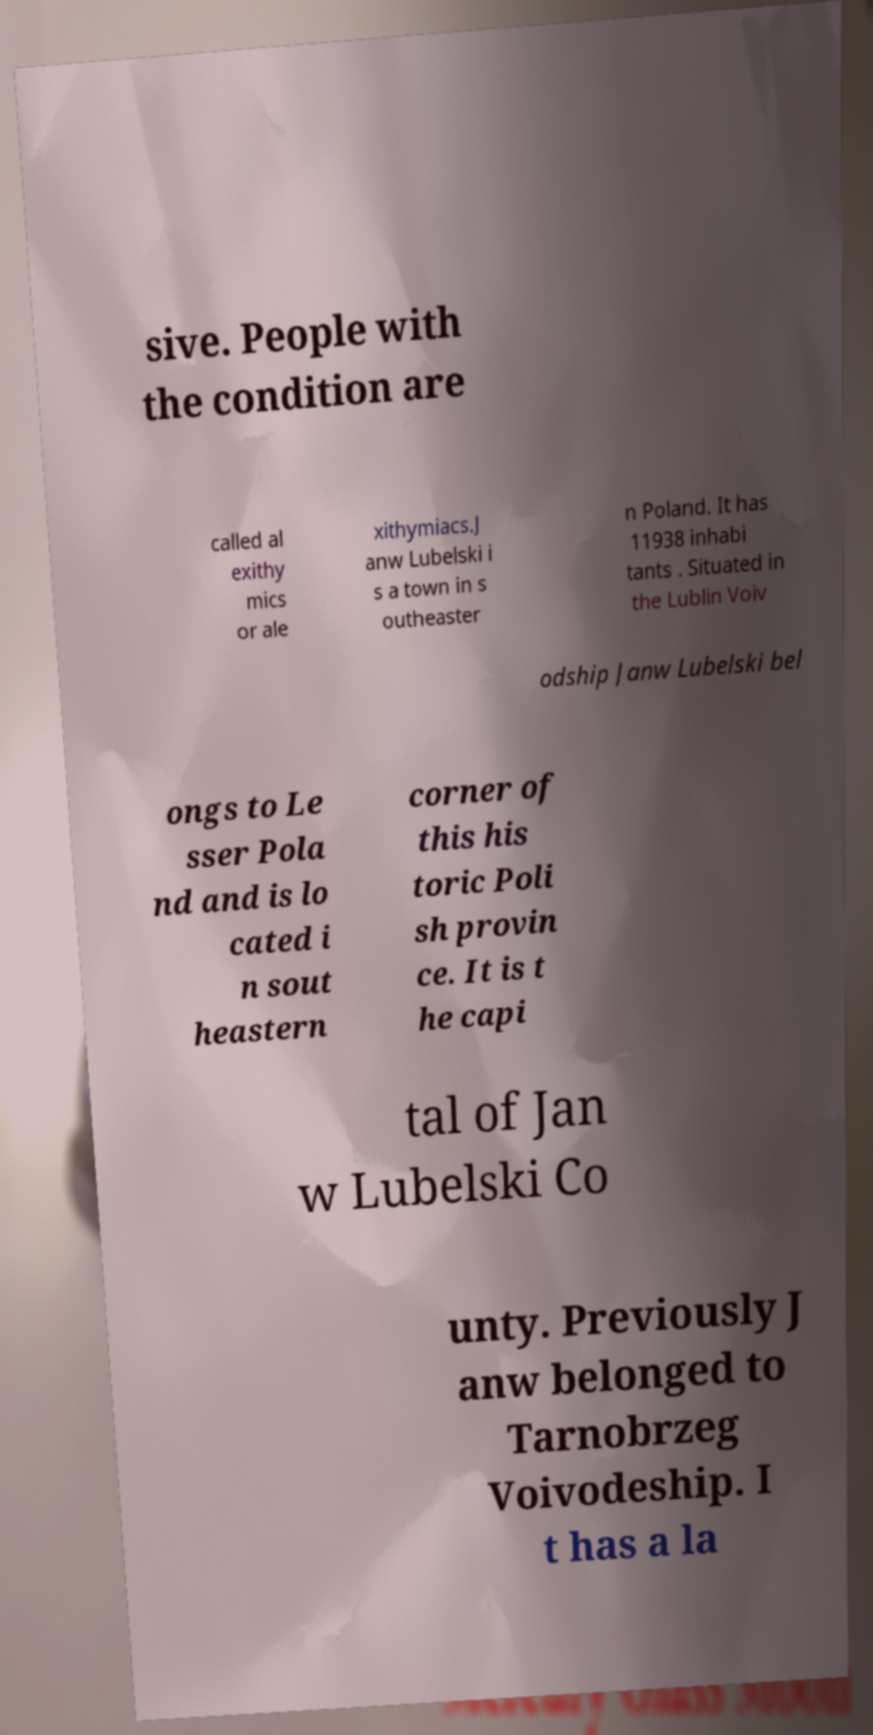I need the written content from this picture converted into text. Can you do that? sive. People with the condition are called al exithy mics or ale xithymiacs.J anw Lubelski i s a town in s outheaster n Poland. It has 11938 inhabi tants . Situated in the Lublin Voiv odship Janw Lubelski bel ongs to Le sser Pola nd and is lo cated i n sout heastern corner of this his toric Poli sh provin ce. It is t he capi tal of Jan w Lubelski Co unty. Previously J anw belonged to Tarnobrzeg Voivodeship. I t has a la 